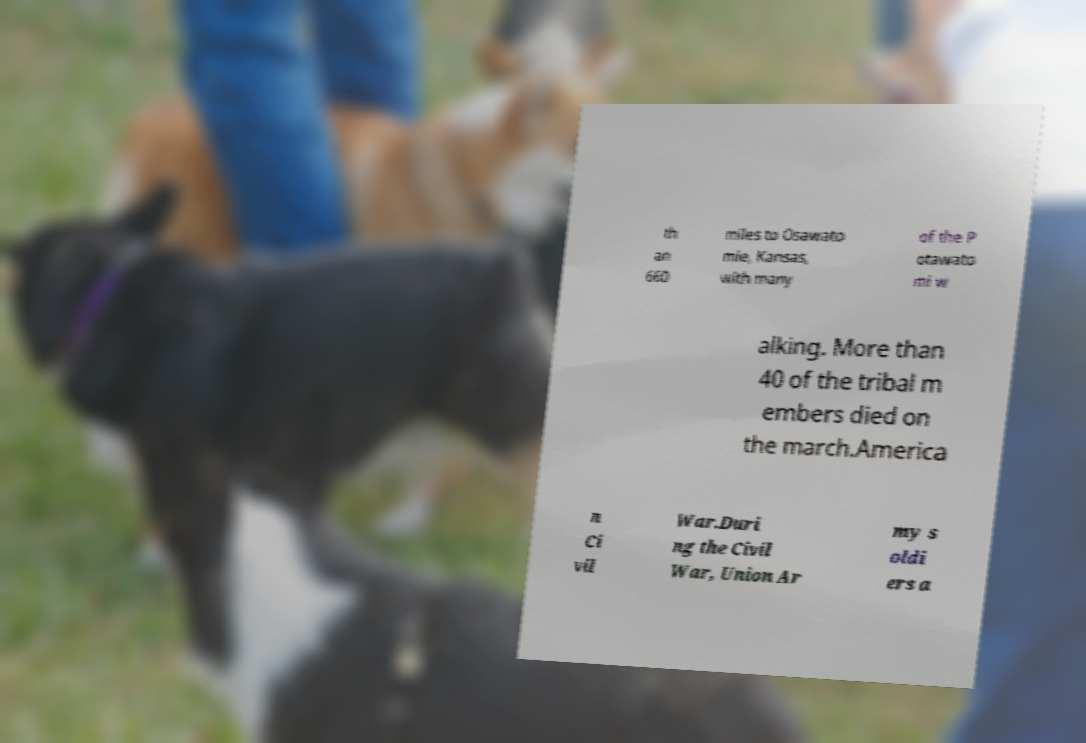For documentation purposes, I need the text within this image transcribed. Could you provide that? th an 660 miles to Osawato mie, Kansas, with many of the P otawato mi w alking. More than 40 of the tribal m embers died on the march.America n Ci vil War.Duri ng the Civil War, Union Ar my s oldi ers a 